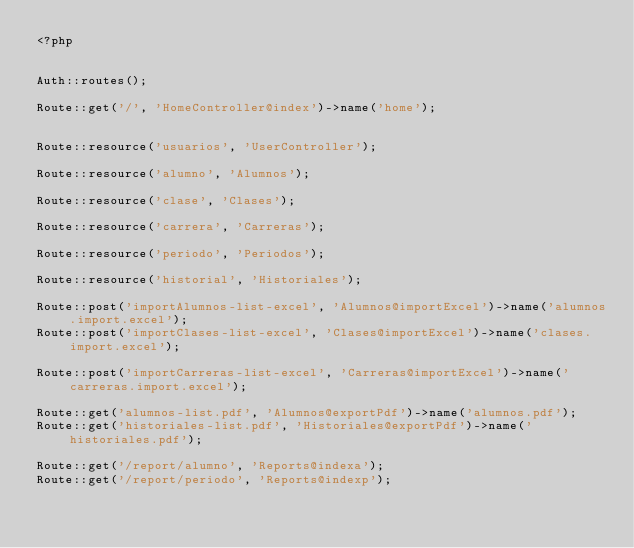<code> <loc_0><loc_0><loc_500><loc_500><_PHP_><?php


Auth::routes();

Route::get('/', 'HomeController@index')->name('home');


Route::resource('usuarios', 'UserController');

Route::resource('alumno', 'Alumnos');

Route::resource('clase', 'Clases');

Route::resource('carrera', 'Carreras');

Route::resource('periodo', 'Periodos');

Route::resource('historial', 'Historiales');

Route::post('importAlumnos-list-excel', 'Alumnos@importExcel')->name('alumnos.import.excel');
Route::post('importClases-list-excel', 'Clases@importExcel')->name('clases.import.excel');

Route::post('importCarreras-list-excel', 'Carreras@importExcel')->name('carreras.import.excel');

Route::get('alumnos-list.pdf', 'Alumnos@exportPdf')->name('alumnos.pdf');
Route::get('historiales-list.pdf', 'Historiales@exportPdf')->name('historiales.pdf');

Route::get('/report/alumno', 'Reports@indexa');
Route::get('/report/periodo', 'Reports@indexp');
</code> 